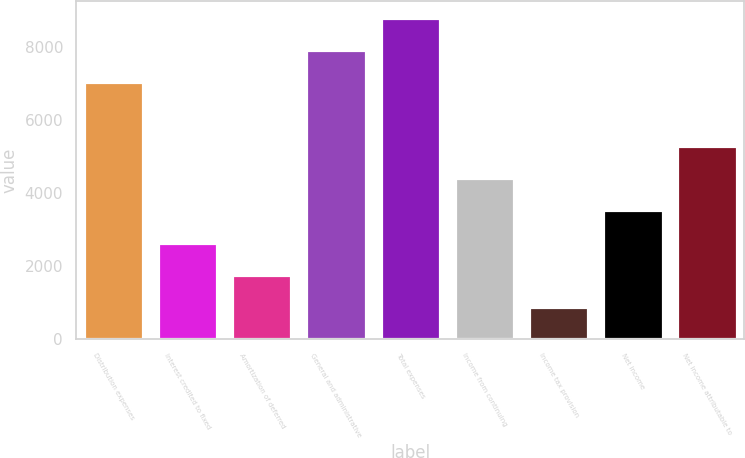<chart> <loc_0><loc_0><loc_500><loc_500><bar_chart><fcel>Distribution expenses<fcel>Interest credited to fixed<fcel>Amortization of deferred<fcel>General and administrative<fcel>Total expenses<fcel>Income from continuing<fcel>Income tax provision<fcel>Net income<fcel>Net income attributable to<nl><fcel>7046.44<fcel>2645.14<fcel>1764.88<fcel>7926.7<fcel>8807<fcel>4405.66<fcel>884.62<fcel>3525.4<fcel>5285.92<nl></chart> 